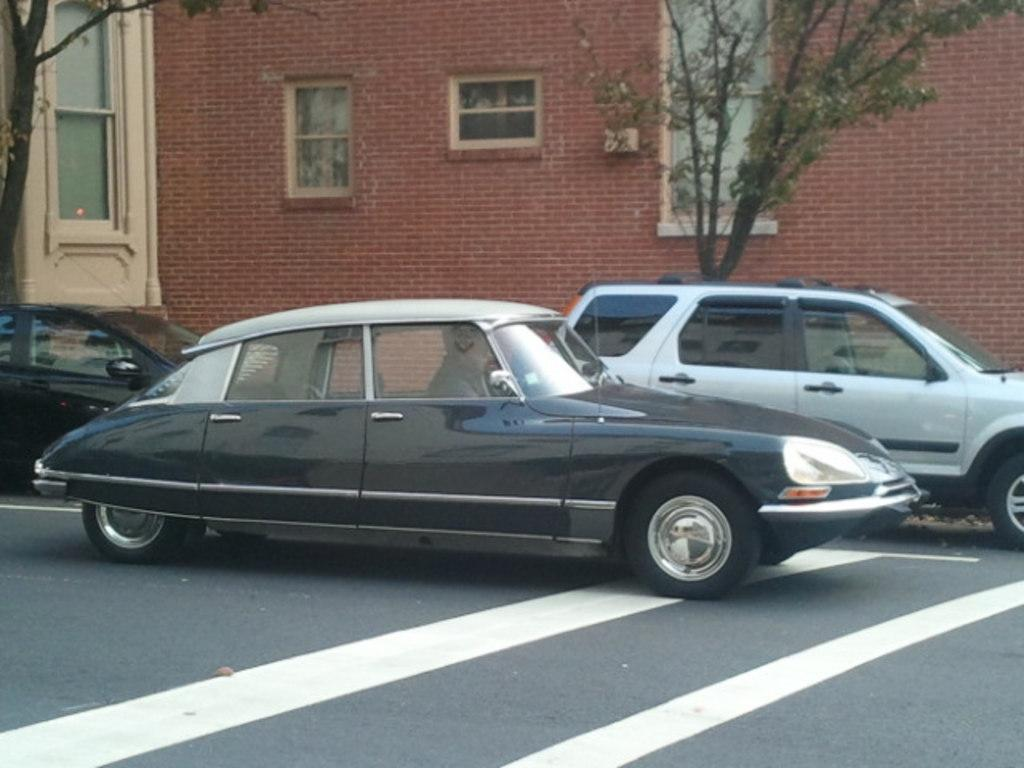What can be seen on the road in the image? There are cars on the road in the image. What type of natural elements are visible in the background of the image? There are trees in the background of the image. What architectural features can be seen in the background of the image? There are windows and at least one building visible in the background of the image. What type of horn is hanging from the pocket of the car in the image? There is no horn or pocket visible on the cars in the image. 